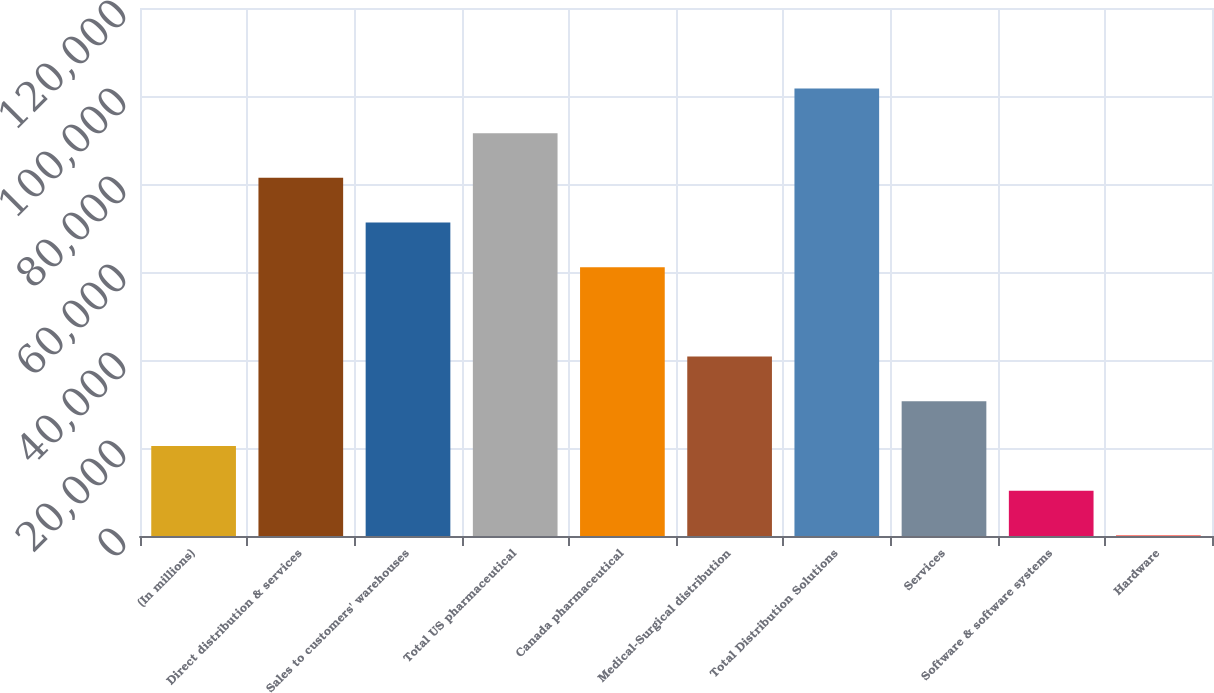<chart> <loc_0><loc_0><loc_500><loc_500><bar_chart><fcel>(In millions)<fcel>Direct distribution & services<fcel>Sales to customers' warehouses<fcel>Total US pharmaceutical<fcel>Canada pharmaceutical<fcel>Medical-Surgical distribution<fcel>Total Distribution Solutions<fcel>Services<fcel>Software & software systems<fcel>Hardware<nl><fcel>20463<fcel>81393<fcel>71238<fcel>91548<fcel>61083<fcel>40773<fcel>101703<fcel>30618<fcel>10308<fcel>153<nl></chart> 